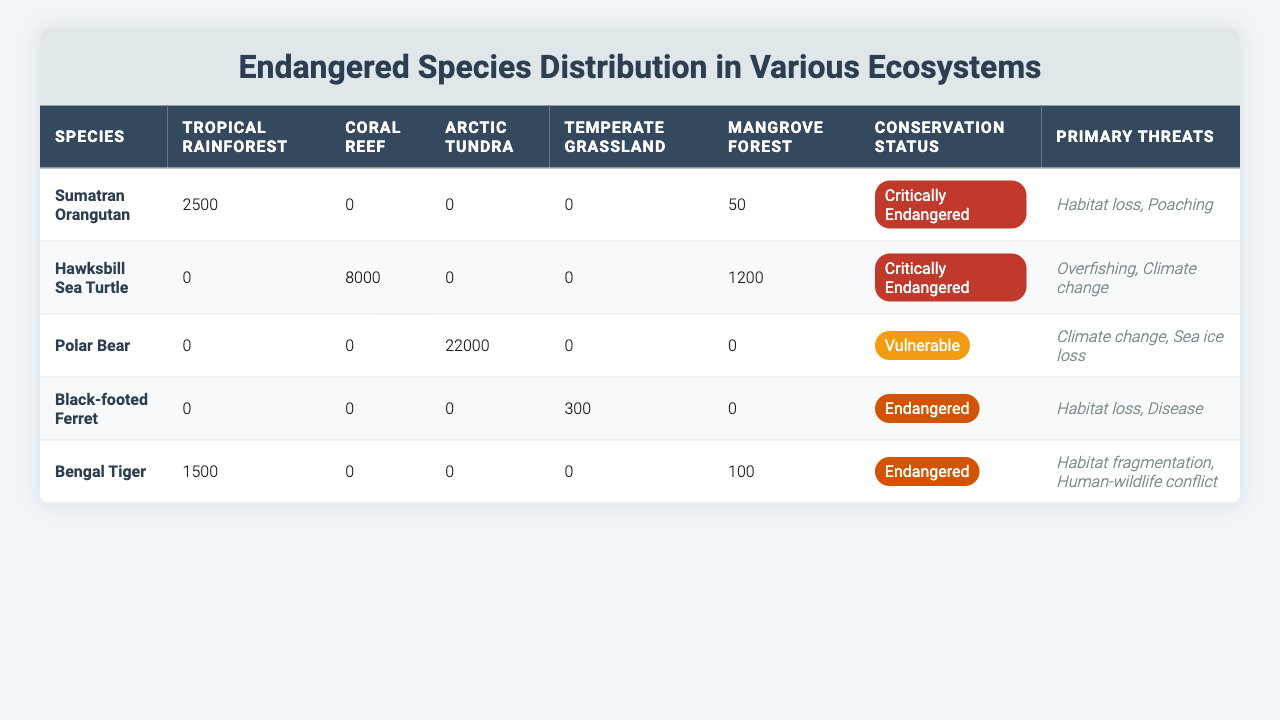What is the highest population count among the endangered species in the Arctic Tundra? The Arctic Tundra has only one species listed, which is the Polar Bear with a count of 22,000. There are no other species present in this ecosystem. Therefore, the highest population count is that of the Polar Bear.
Answer: 22,000 Which ecosystem has the most individuals of the Hawksbill Sea Turtle? The Hawksbill Sea Turtle has a population count of 8,000 individuals in the Coral Reef ecosystem, which is the only ecosystem where this species is found.
Answer: Coral Reef How many Bengal Tigers are distributed across the Tropical Rainforest and Mangrove Forest combined? The Bengal Tiger has 1,500 individuals in the Tropical Rainforest and 100 in the Mangrove Forest. Adding these two values together gives 1,500 + 100 = 1,600.
Answer: 1,600 Is there any endangered species found in the Temperate Grassland? The table shows the Black-footed Ferret as the only species in the Temperate Grassland, which has a population count of 300, confirming that there is indeed an endangered species present in this ecosystem.
Answer: Yes Which species has the highest conservation status among those listed, and what is that status? The species with the highest conservation status listed in the table is the Sumatran Orangutan, classified as "Critically Endangered." This status is higher than the other classifications provided.
Answer: Sumatran Orangutan, Critically Endangered What is the total number of endangered species that are critically endangered? The table indicates that both the Sumatran Orangutan and the Hawksbill Sea Turtle are classified as "Critically Endangered." Therefore, 2 species are critically endangered.
Answer: 2 What is the primary threat to the Polar Bear? The primary threats to the Polar Bear listed in the table are "Climate change" and "Sea ice loss," which indicates the factors affecting their survival in the Arctic Tundra.
Answer: Climate change, Sea ice loss In which ecosystem does the Black-footed Ferret have the highest count, and what is that count? The Black-footed Ferret only has a distribution in the Temperate Grassland, with a count of 300 individuals. As there are no other counts in other ecosystems, this is the highest count for this species.
Answer: Temperate Grassland, 300 What is the difference in population counts between the Sumatran Orangutan and the Hawksbill Sea Turtle across all ecosystems? The Sumatran Orangutan has a total of 2,550 (2,500 in Tropical Rainforest and 50 in Mangrove Forest), while the Hawksbill Sea Turtle has 9,200 (8,000 in Coral Reef and 1,200 in Mangrove Forest). To find the difference, calculate 9,200 - 2,550 = 6,650.
Answer: 6,650 Which ecosystem has no endangered species present at all? The representation in the table shows that there are no endangered species found in the Coral Reef ecosystem. This is confirmed as it has a count of zero for all the species listed.
Answer: Coral Reef 